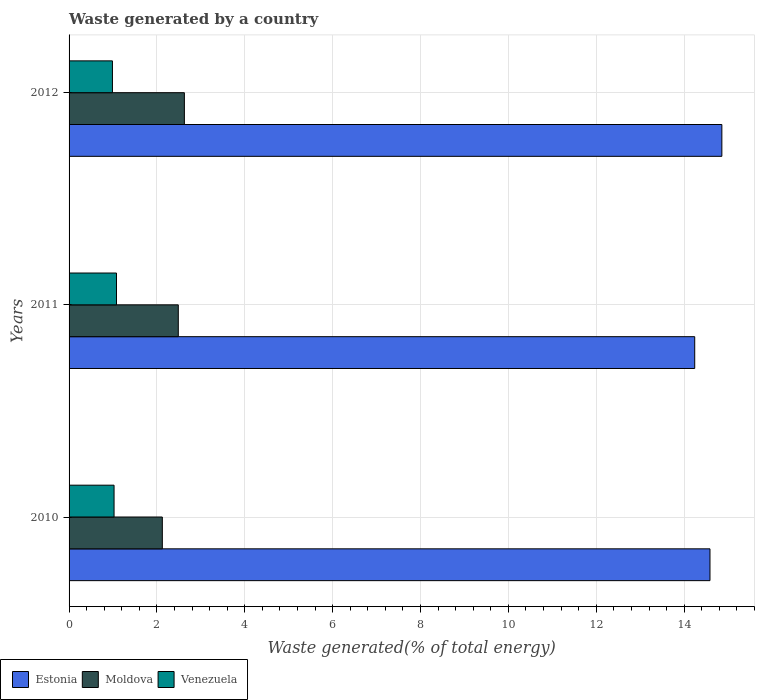How many groups of bars are there?
Offer a terse response. 3. Are the number of bars per tick equal to the number of legend labels?
Provide a short and direct response. Yes. Are the number of bars on each tick of the Y-axis equal?
Your answer should be very brief. Yes. How many bars are there on the 2nd tick from the top?
Your response must be concise. 3. What is the label of the 2nd group of bars from the top?
Offer a very short reply. 2011. What is the total waste generated in Venezuela in 2011?
Your response must be concise. 1.08. Across all years, what is the maximum total waste generated in Moldova?
Provide a short and direct response. 2.62. Across all years, what is the minimum total waste generated in Estonia?
Provide a short and direct response. 14.24. In which year was the total waste generated in Estonia minimum?
Your answer should be compact. 2011. What is the total total waste generated in Venezuela in the graph?
Provide a short and direct response. 3.09. What is the difference between the total waste generated in Estonia in 2010 and that in 2012?
Your answer should be compact. -0.27. What is the difference between the total waste generated in Moldova in 2010 and the total waste generated in Venezuela in 2011?
Ensure brevity in your answer.  1.04. What is the average total waste generated in Moldova per year?
Provide a succinct answer. 2.41. In the year 2010, what is the difference between the total waste generated in Venezuela and total waste generated in Moldova?
Keep it short and to the point. -1.1. In how many years, is the total waste generated in Moldova greater than 9.6 %?
Your answer should be very brief. 0. What is the ratio of the total waste generated in Venezuela in 2010 to that in 2012?
Provide a succinct answer. 1.04. Is the total waste generated in Venezuela in 2011 less than that in 2012?
Give a very brief answer. No. What is the difference between the highest and the second highest total waste generated in Venezuela?
Give a very brief answer. 0.06. What is the difference between the highest and the lowest total waste generated in Moldova?
Keep it short and to the point. 0.5. Is the sum of the total waste generated in Moldova in 2010 and 2012 greater than the maximum total waste generated in Estonia across all years?
Provide a short and direct response. No. What does the 2nd bar from the top in 2011 represents?
Offer a terse response. Moldova. What does the 2nd bar from the bottom in 2010 represents?
Offer a terse response. Moldova. Are all the bars in the graph horizontal?
Provide a succinct answer. Yes. What is the difference between two consecutive major ticks on the X-axis?
Your answer should be compact. 2. Does the graph contain any zero values?
Provide a short and direct response. No. Does the graph contain grids?
Ensure brevity in your answer.  Yes. Where does the legend appear in the graph?
Your answer should be very brief. Bottom left. How many legend labels are there?
Ensure brevity in your answer.  3. What is the title of the graph?
Offer a terse response. Waste generated by a country. Does "Niger" appear as one of the legend labels in the graph?
Your answer should be very brief. No. What is the label or title of the X-axis?
Provide a succinct answer. Waste generated(% of total energy). What is the Waste generated(% of total energy) of Estonia in 2010?
Your response must be concise. 14.59. What is the Waste generated(% of total energy) in Moldova in 2010?
Make the answer very short. 2.12. What is the Waste generated(% of total energy) in Venezuela in 2010?
Your answer should be very brief. 1.02. What is the Waste generated(% of total energy) in Estonia in 2011?
Your response must be concise. 14.24. What is the Waste generated(% of total energy) of Moldova in 2011?
Give a very brief answer. 2.49. What is the Waste generated(% of total energy) of Venezuela in 2011?
Provide a short and direct response. 1.08. What is the Waste generated(% of total energy) of Estonia in 2012?
Your answer should be very brief. 14.86. What is the Waste generated(% of total energy) of Moldova in 2012?
Provide a short and direct response. 2.62. What is the Waste generated(% of total energy) of Venezuela in 2012?
Offer a terse response. 0.99. Across all years, what is the maximum Waste generated(% of total energy) of Estonia?
Provide a short and direct response. 14.86. Across all years, what is the maximum Waste generated(% of total energy) of Moldova?
Ensure brevity in your answer.  2.62. Across all years, what is the maximum Waste generated(% of total energy) of Venezuela?
Keep it short and to the point. 1.08. Across all years, what is the minimum Waste generated(% of total energy) of Estonia?
Offer a very short reply. 14.24. Across all years, what is the minimum Waste generated(% of total energy) of Moldova?
Ensure brevity in your answer.  2.12. Across all years, what is the minimum Waste generated(% of total energy) of Venezuela?
Offer a very short reply. 0.99. What is the total Waste generated(% of total energy) of Estonia in the graph?
Your response must be concise. 43.69. What is the total Waste generated(% of total energy) in Moldova in the graph?
Offer a terse response. 7.23. What is the total Waste generated(% of total energy) in Venezuela in the graph?
Ensure brevity in your answer.  3.09. What is the difference between the Waste generated(% of total energy) of Estonia in 2010 and that in 2011?
Offer a terse response. 0.35. What is the difference between the Waste generated(% of total energy) of Moldova in 2010 and that in 2011?
Your answer should be compact. -0.36. What is the difference between the Waste generated(% of total energy) of Venezuela in 2010 and that in 2011?
Your answer should be very brief. -0.06. What is the difference between the Waste generated(% of total energy) of Estonia in 2010 and that in 2012?
Provide a short and direct response. -0.27. What is the difference between the Waste generated(% of total energy) of Moldova in 2010 and that in 2012?
Make the answer very short. -0.5. What is the difference between the Waste generated(% of total energy) in Venezuela in 2010 and that in 2012?
Offer a terse response. 0.04. What is the difference between the Waste generated(% of total energy) of Estonia in 2011 and that in 2012?
Give a very brief answer. -0.62. What is the difference between the Waste generated(% of total energy) in Moldova in 2011 and that in 2012?
Your response must be concise. -0.14. What is the difference between the Waste generated(% of total energy) in Venezuela in 2011 and that in 2012?
Make the answer very short. 0.09. What is the difference between the Waste generated(% of total energy) of Estonia in 2010 and the Waste generated(% of total energy) of Moldova in 2011?
Keep it short and to the point. 12.1. What is the difference between the Waste generated(% of total energy) in Estonia in 2010 and the Waste generated(% of total energy) in Venezuela in 2011?
Keep it short and to the point. 13.51. What is the difference between the Waste generated(% of total energy) of Moldova in 2010 and the Waste generated(% of total energy) of Venezuela in 2011?
Offer a very short reply. 1.04. What is the difference between the Waste generated(% of total energy) in Estonia in 2010 and the Waste generated(% of total energy) in Moldova in 2012?
Your answer should be very brief. 11.96. What is the difference between the Waste generated(% of total energy) in Estonia in 2010 and the Waste generated(% of total energy) in Venezuela in 2012?
Offer a terse response. 13.6. What is the difference between the Waste generated(% of total energy) of Moldova in 2010 and the Waste generated(% of total energy) of Venezuela in 2012?
Your response must be concise. 1.14. What is the difference between the Waste generated(% of total energy) in Estonia in 2011 and the Waste generated(% of total energy) in Moldova in 2012?
Offer a terse response. 11.62. What is the difference between the Waste generated(% of total energy) of Estonia in 2011 and the Waste generated(% of total energy) of Venezuela in 2012?
Keep it short and to the point. 13.25. What is the difference between the Waste generated(% of total energy) of Moldova in 2011 and the Waste generated(% of total energy) of Venezuela in 2012?
Your answer should be very brief. 1.5. What is the average Waste generated(% of total energy) of Estonia per year?
Keep it short and to the point. 14.56. What is the average Waste generated(% of total energy) of Moldova per year?
Offer a very short reply. 2.41. What is the average Waste generated(% of total energy) of Venezuela per year?
Keep it short and to the point. 1.03. In the year 2010, what is the difference between the Waste generated(% of total energy) of Estonia and Waste generated(% of total energy) of Moldova?
Your answer should be very brief. 12.47. In the year 2010, what is the difference between the Waste generated(% of total energy) in Estonia and Waste generated(% of total energy) in Venezuela?
Provide a short and direct response. 13.56. In the year 2010, what is the difference between the Waste generated(% of total energy) of Moldova and Waste generated(% of total energy) of Venezuela?
Your answer should be very brief. 1.1. In the year 2011, what is the difference between the Waste generated(% of total energy) in Estonia and Waste generated(% of total energy) in Moldova?
Your response must be concise. 11.75. In the year 2011, what is the difference between the Waste generated(% of total energy) in Estonia and Waste generated(% of total energy) in Venezuela?
Your response must be concise. 13.16. In the year 2011, what is the difference between the Waste generated(% of total energy) in Moldova and Waste generated(% of total energy) in Venezuela?
Give a very brief answer. 1.41. In the year 2012, what is the difference between the Waste generated(% of total energy) in Estonia and Waste generated(% of total energy) in Moldova?
Your answer should be compact. 12.23. In the year 2012, what is the difference between the Waste generated(% of total energy) of Estonia and Waste generated(% of total energy) of Venezuela?
Keep it short and to the point. 13.87. In the year 2012, what is the difference between the Waste generated(% of total energy) of Moldova and Waste generated(% of total energy) of Venezuela?
Keep it short and to the point. 1.64. What is the ratio of the Waste generated(% of total energy) in Estonia in 2010 to that in 2011?
Your answer should be very brief. 1.02. What is the ratio of the Waste generated(% of total energy) in Moldova in 2010 to that in 2011?
Provide a succinct answer. 0.85. What is the ratio of the Waste generated(% of total energy) in Venezuela in 2010 to that in 2011?
Keep it short and to the point. 0.95. What is the ratio of the Waste generated(% of total energy) of Estonia in 2010 to that in 2012?
Your answer should be very brief. 0.98. What is the ratio of the Waste generated(% of total energy) of Moldova in 2010 to that in 2012?
Offer a terse response. 0.81. What is the ratio of the Waste generated(% of total energy) in Venezuela in 2010 to that in 2012?
Ensure brevity in your answer.  1.04. What is the ratio of the Waste generated(% of total energy) in Estonia in 2011 to that in 2012?
Give a very brief answer. 0.96. What is the ratio of the Waste generated(% of total energy) in Moldova in 2011 to that in 2012?
Provide a succinct answer. 0.95. What is the ratio of the Waste generated(% of total energy) of Venezuela in 2011 to that in 2012?
Your answer should be compact. 1.09. What is the difference between the highest and the second highest Waste generated(% of total energy) in Estonia?
Make the answer very short. 0.27. What is the difference between the highest and the second highest Waste generated(% of total energy) in Moldova?
Provide a succinct answer. 0.14. What is the difference between the highest and the second highest Waste generated(% of total energy) of Venezuela?
Give a very brief answer. 0.06. What is the difference between the highest and the lowest Waste generated(% of total energy) of Estonia?
Keep it short and to the point. 0.62. What is the difference between the highest and the lowest Waste generated(% of total energy) in Moldova?
Keep it short and to the point. 0.5. What is the difference between the highest and the lowest Waste generated(% of total energy) in Venezuela?
Offer a very short reply. 0.09. 